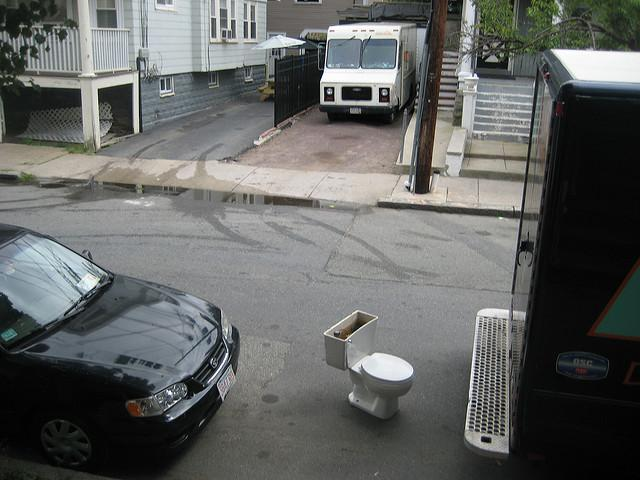What is between the car and the cube truck? Please explain your reasoning. toilet. This has a tank and a lid 